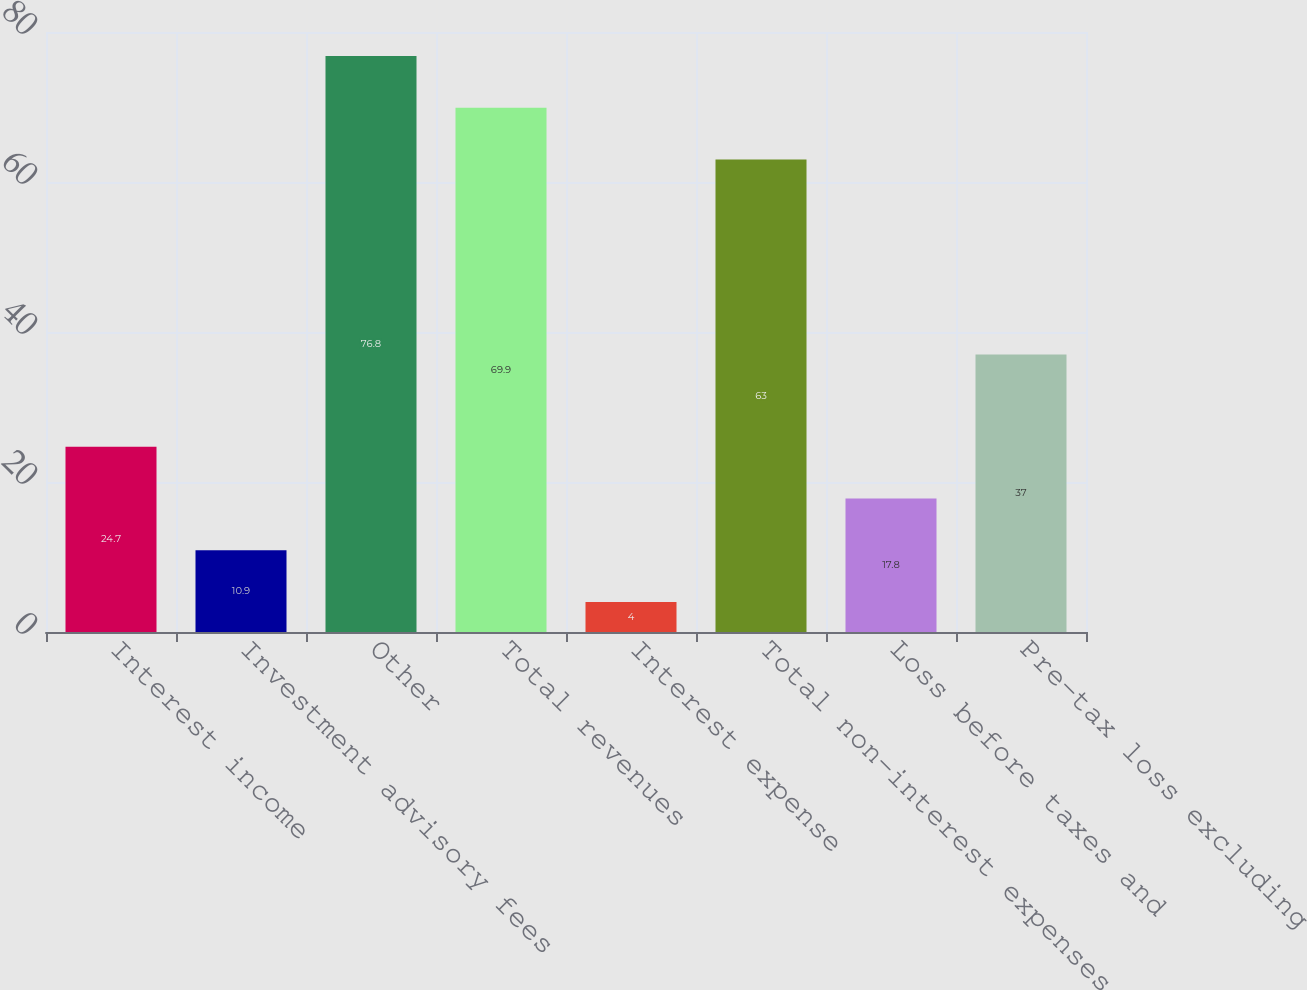<chart> <loc_0><loc_0><loc_500><loc_500><bar_chart><fcel>Interest income<fcel>Investment advisory fees<fcel>Other<fcel>Total revenues<fcel>Interest expense<fcel>Total non-interest expenses<fcel>Loss before taxes and<fcel>Pre-tax loss excluding<nl><fcel>24.7<fcel>10.9<fcel>76.8<fcel>69.9<fcel>4<fcel>63<fcel>17.8<fcel>37<nl></chart> 